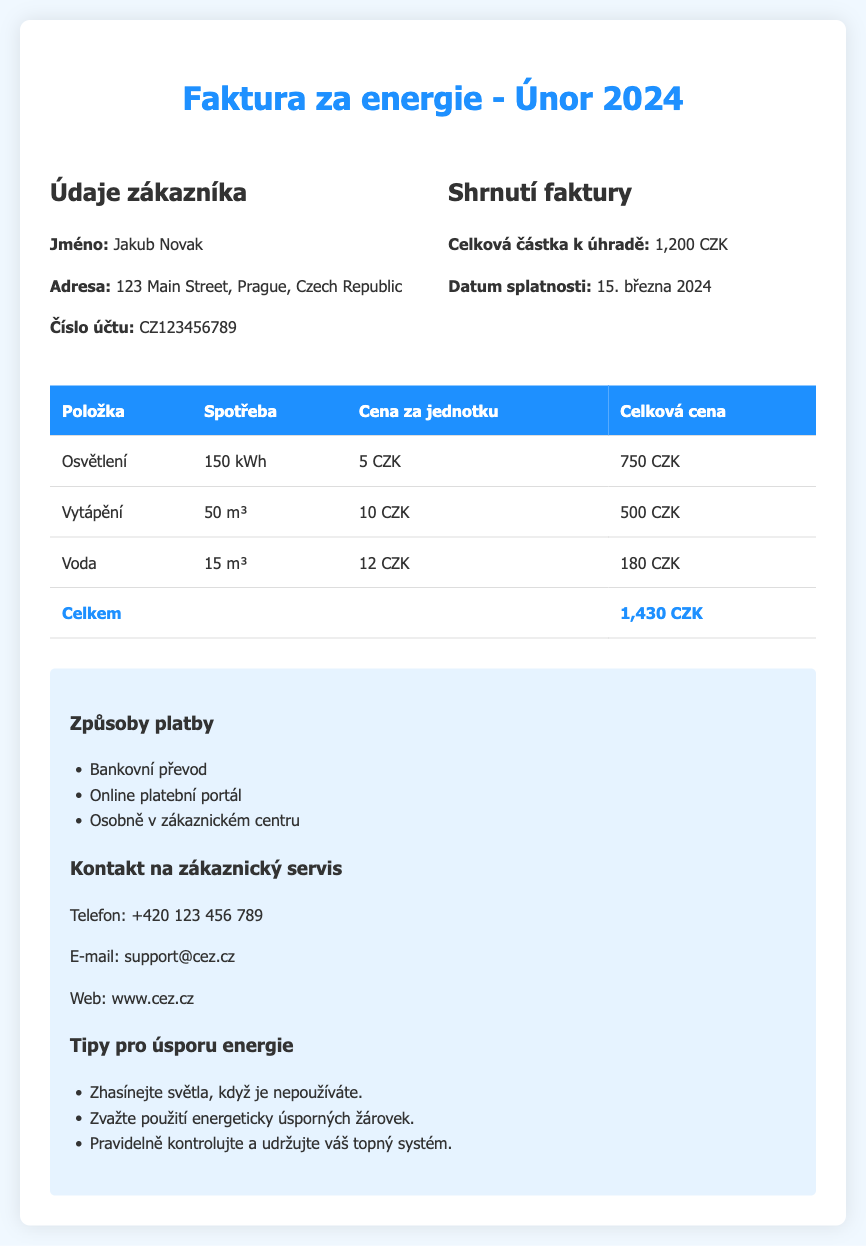What is the customer's name? The customer's name is listed in the customer details section of the document.
Answer: Jakub Novak What is the total amount to be paid? The total amount to be paid is specified in the billing summary section.
Answer: 1,200 CZK What is the payment due date? The payment due date is mentioned in the billing summary section of the document.
Answer: 15. března 2024 How much is charged for lighting? The charge for lighting can be found in the breakdown table of charges.
Answer: 750 CZK What is the water consumption in the bill? The water consumption is stated in the table of charges, under the water usage item.
Answer: 15 m³ What is the charge per unit for heating? The charge per unit for heating is indicated in the charges table.
Answer: 10 CZK How much is the total for all utility charges? The total for all utility charges is calculated by adding all individual charges in the breakdown table.
Answer: 1,430 CZK What is the contact phone number for customer service? The customer service contact phone number is provided in the additional information section.
Answer: +420 123 456 789 Which payment method is mentioned for online payment? The different payment methods listed in the document include specific options for payment.
Answer: Online platební portál 